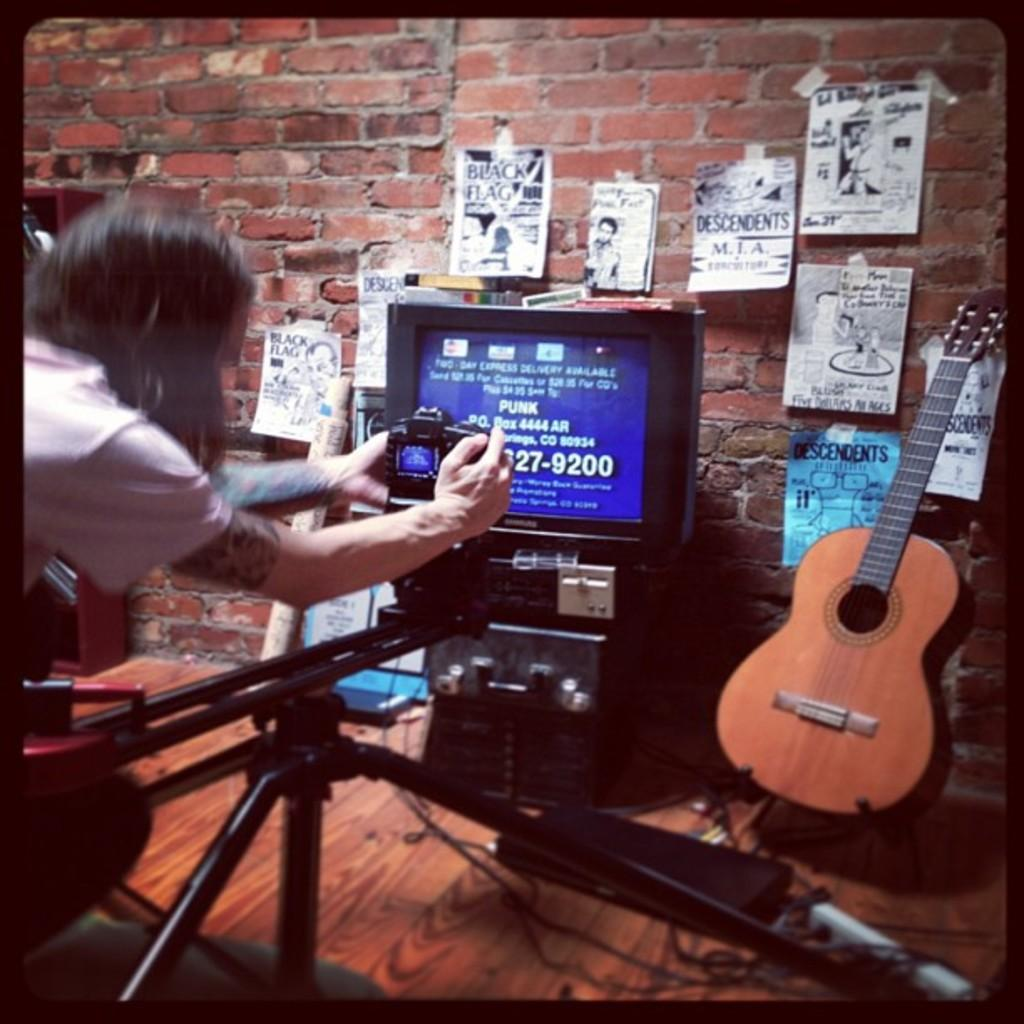Who is present in the image? There is a woman in the image. What type of structure is visible in the image? There is a brick wall in the image. What device is present in the image? There is a screen in the image. What is the purpose of the device in the image? The screen is likely part of a camera, as there is a camera present in the image. What object is associated with music in the image? There is a guitar in the image. What type of joke is the woman telling in the image? There is no indication of a joke being told in the image; the woman is not speaking or interacting with anyone. 